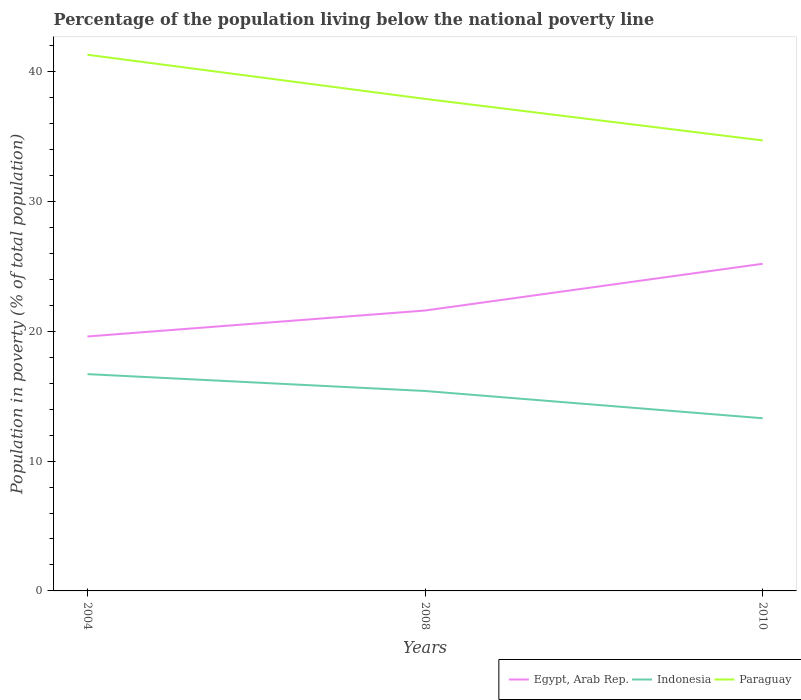Does the line corresponding to Indonesia intersect with the line corresponding to Egypt, Arab Rep.?
Keep it short and to the point. No. Is the number of lines equal to the number of legend labels?
Offer a terse response. Yes. Across all years, what is the maximum percentage of the population living below the national poverty line in Egypt, Arab Rep.?
Ensure brevity in your answer.  19.6. In which year was the percentage of the population living below the national poverty line in Paraguay maximum?
Your response must be concise. 2010. What is the total percentage of the population living below the national poverty line in Egypt, Arab Rep. in the graph?
Make the answer very short. -2. What is the difference between the highest and the second highest percentage of the population living below the national poverty line in Indonesia?
Your response must be concise. 3.4. Is the percentage of the population living below the national poverty line in Paraguay strictly greater than the percentage of the population living below the national poverty line in Egypt, Arab Rep. over the years?
Give a very brief answer. No. How many lines are there?
Ensure brevity in your answer.  3. How many years are there in the graph?
Your response must be concise. 3. What is the difference between two consecutive major ticks on the Y-axis?
Ensure brevity in your answer.  10. How are the legend labels stacked?
Make the answer very short. Horizontal. What is the title of the graph?
Provide a succinct answer. Percentage of the population living below the national poverty line. What is the label or title of the X-axis?
Provide a short and direct response. Years. What is the label or title of the Y-axis?
Your answer should be very brief. Population in poverty (% of total population). What is the Population in poverty (% of total population) in Egypt, Arab Rep. in 2004?
Your answer should be compact. 19.6. What is the Population in poverty (% of total population) in Indonesia in 2004?
Ensure brevity in your answer.  16.7. What is the Population in poverty (% of total population) of Paraguay in 2004?
Give a very brief answer. 41.3. What is the Population in poverty (% of total population) of Egypt, Arab Rep. in 2008?
Your answer should be very brief. 21.6. What is the Population in poverty (% of total population) of Paraguay in 2008?
Make the answer very short. 37.9. What is the Population in poverty (% of total population) in Egypt, Arab Rep. in 2010?
Keep it short and to the point. 25.2. What is the Population in poverty (% of total population) in Indonesia in 2010?
Keep it short and to the point. 13.3. What is the Population in poverty (% of total population) of Paraguay in 2010?
Provide a succinct answer. 34.7. Across all years, what is the maximum Population in poverty (% of total population) in Egypt, Arab Rep.?
Offer a terse response. 25.2. Across all years, what is the maximum Population in poverty (% of total population) of Indonesia?
Provide a succinct answer. 16.7. Across all years, what is the maximum Population in poverty (% of total population) in Paraguay?
Provide a short and direct response. 41.3. Across all years, what is the minimum Population in poverty (% of total population) in Egypt, Arab Rep.?
Your answer should be compact. 19.6. Across all years, what is the minimum Population in poverty (% of total population) of Indonesia?
Make the answer very short. 13.3. Across all years, what is the minimum Population in poverty (% of total population) of Paraguay?
Provide a short and direct response. 34.7. What is the total Population in poverty (% of total population) in Egypt, Arab Rep. in the graph?
Your answer should be very brief. 66.4. What is the total Population in poverty (% of total population) of Indonesia in the graph?
Make the answer very short. 45.4. What is the total Population in poverty (% of total population) of Paraguay in the graph?
Provide a succinct answer. 113.9. What is the difference between the Population in poverty (% of total population) of Egypt, Arab Rep. in 2004 and that in 2008?
Provide a succinct answer. -2. What is the difference between the Population in poverty (% of total population) of Indonesia in 2004 and that in 2008?
Ensure brevity in your answer.  1.3. What is the difference between the Population in poverty (% of total population) of Paraguay in 2004 and that in 2008?
Keep it short and to the point. 3.4. What is the difference between the Population in poverty (% of total population) of Egypt, Arab Rep. in 2004 and that in 2010?
Give a very brief answer. -5.6. What is the difference between the Population in poverty (% of total population) of Indonesia in 2004 and that in 2010?
Give a very brief answer. 3.4. What is the difference between the Population in poverty (% of total population) in Paraguay in 2004 and that in 2010?
Provide a short and direct response. 6.6. What is the difference between the Population in poverty (% of total population) of Egypt, Arab Rep. in 2008 and that in 2010?
Keep it short and to the point. -3.6. What is the difference between the Population in poverty (% of total population) in Paraguay in 2008 and that in 2010?
Ensure brevity in your answer.  3.2. What is the difference between the Population in poverty (% of total population) in Egypt, Arab Rep. in 2004 and the Population in poverty (% of total population) in Indonesia in 2008?
Offer a terse response. 4.2. What is the difference between the Population in poverty (% of total population) of Egypt, Arab Rep. in 2004 and the Population in poverty (% of total population) of Paraguay in 2008?
Provide a succinct answer. -18.3. What is the difference between the Population in poverty (% of total population) of Indonesia in 2004 and the Population in poverty (% of total population) of Paraguay in 2008?
Make the answer very short. -21.2. What is the difference between the Population in poverty (% of total population) in Egypt, Arab Rep. in 2004 and the Population in poverty (% of total population) in Paraguay in 2010?
Your answer should be very brief. -15.1. What is the difference between the Population in poverty (% of total population) in Indonesia in 2004 and the Population in poverty (% of total population) in Paraguay in 2010?
Make the answer very short. -18. What is the difference between the Population in poverty (% of total population) of Egypt, Arab Rep. in 2008 and the Population in poverty (% of total population) of Indonesia in 2010?
Keep it short and to the point. 8.3. What is the difference between the Population in poverty (% of total population) of Egypt, Arab Rep. in 2008 and the Population in poverty (% of total population) of Paraguay in 2010?
Your answer should be very brief. -13.1. What is the difference between the Population in poverty (% of total population) of Indonesia in 2008 and the Population in poverty (% of total population) of Paraguay in 2010?
Your response must be concise. -19.3. What is the average Population in poverty (% of total population) of Egypt, Arab Rep. per year?
Offer a very short reply. 22.13. What is the average Population in poverty (% of total population) of Indonesia per year?
Your answer should be compact. 15.13. What is the average Population in poverty (% of total population) of Paraguay per year?
Make the answer very short. 37.97. In the year 2004, what is the difference between the Population in poverty (% of total population) of Egypt, Arab Rep. and Population in poverty (% of total population) of Paraguay?
Provide a short and direct response. -21.7. In the year 2004, what is the difference between the Population in poverty (% of total population) in Indonesia and Population in poverty (% of total population) in Paraguay?
Provide a short and direct response. -24.6. In the year 2008, what is the difference between the Population in poverty (% of total population) in Egypt, Arab Rep. and Population in poverty (% of total population) in Paraguay?
Make the answer very short. -16.3. In the year 2008, what is the difference between the Population in poverty (% of total population) in Indonesia and Population in poverty (% of total population) in Paraguay?
Keep it short and to the point. -22.5. In the year 2010, what is the difference between the Population in poverty (% of total population) of Egypt, Arab Rep. and Population in poverty (% of total population) of Indonesia?
Offer a terse response. 11.9. In the year 2010, what is the difference between the Population in poverty (% of total population) of Egypt, Arab Rep. and Population in poverty (% of total population) of Paraguay?
Give a very brief answer. -9.5. In the year 2010, what is the difference between the Population in poverty (% of total population) of Indonesia and Population in poverty (% of total population) of Paraguay?
Keep it short and to the point. -21.4. What is the ratio of the Population in poverty (% of total population) in Egypt, Arab Rep. in 2004 to that in 2008?
Make the answer very short. 0.91. What is the ratio of the Population in poverty (% of total population) in Indonesia in 2004 to that in 2008?
Provide a succinct answer. 1.08. What is the ratio of the Population in poverty (% of total population) in Paraguay in 2004 to that in 2008?
Give a very brief answer. 1.09. What is the ratio of the Population in poverty (% of total population) in Egypt, Arab Rep. in 2004 to that in 2010?
Your answer should be very brief. 0.78. What is the ratio of the Population in poverty (% of total population) of Indonesia in 2004 to that in 2010?
Make the answer very short. 1.26. What is the ratio of the Population in poverty (% of total population) of Paraguay in 2004 to that in 2010?
Keep it short and to the point. 1.19. What is the ratio of the Population in poverty (% of total population) of Egypt, Arab Rep. in 2008 to that in 2010?
Your response must be concise. 0.86. What is the ratio of the Population in poverty (% of total population) of Indonesia in 2008 to that in 2010?
Make the answer very short. 1.16. What is the ratio of the Population in poverty (% of total population) of Paraguay in 2008 to that in 2010?
Your response must be concise. 1.09. What is the difference between the highest and the second highest Population in poverty (% of total population) of Indonesia?
Provide a succinct answer. 1.3. What is the difference between the highest and the lowest Population in poverty (% of total population) of Egypt, Arab Rep.?
Offer a very short reply. 5.6. What is the difference between the highest and the lowest Population in poverty (% of total population) in Indonesia?
Your answer should be very brief. 3.4. What is the difference between the highest and the lowest Population in poverty (% of total population) in Paraguay?
Give a very brief answer. 6.6. 